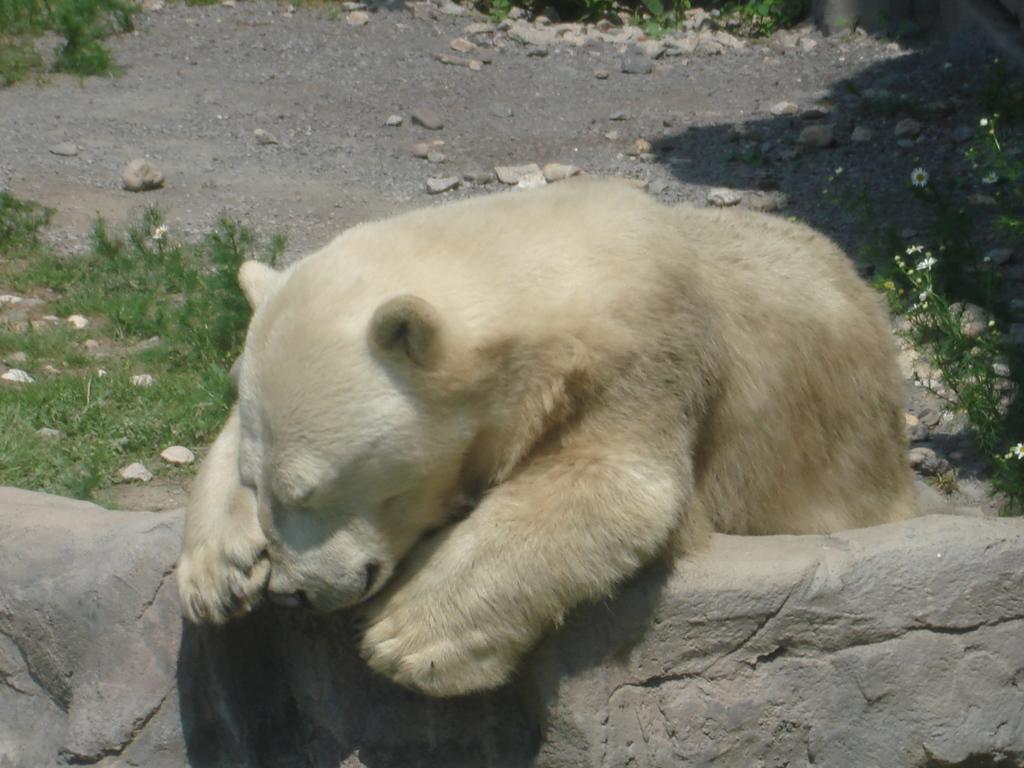In one or two sentences, can you explain what this image depicts? In this picture we can observe a white color polar bear. There are some stones on the ground. We can observe some plants on the land. 